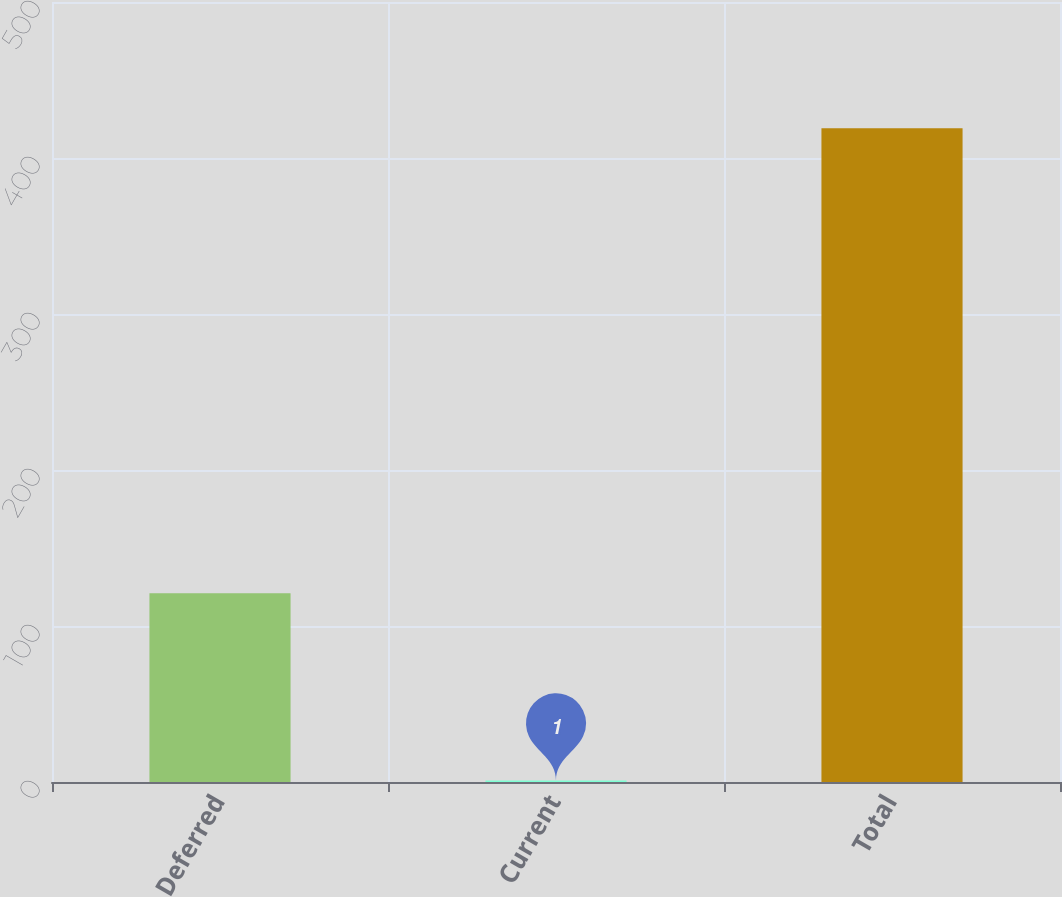Convert chart to OTSL. <chart><loc_0><loc_0><loc_500><loc_500><bar_chart><fcel>Deferred<fcel>Current<fcel>Total<nl><fcel>121<fcel>1<fcel>419<nl></chart> 